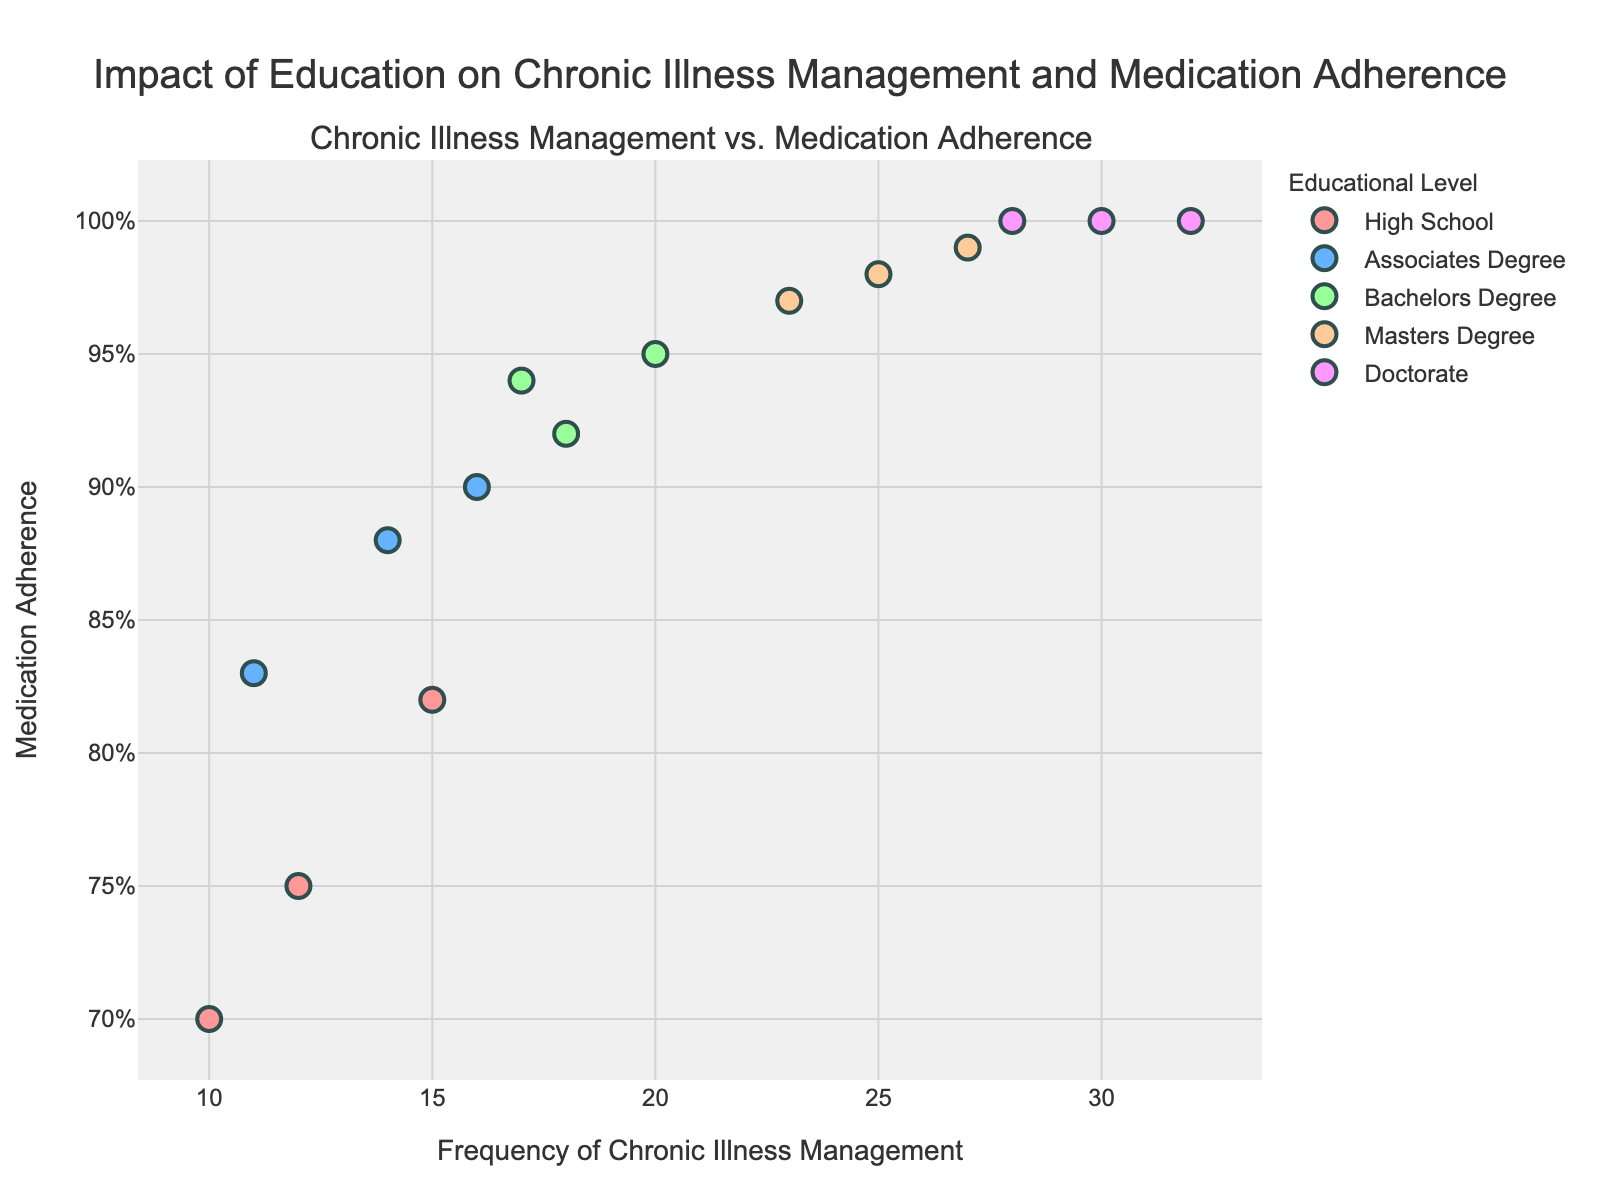Which educational level has the highest frequency of chronic illness management? The educational levels represented in the plot are High School, Associates Degree, Bachelors Degree, Masters Degree, and Doctorate. The Doctorate level has the highest frequency of chronic illness management with values of 30 and 32.
Answer: Doctorate What is the Medication Adherence rate for those with a Master's Degree and a frequency of chronic illness management of 27? From the figure, we can see that the data point for a Master's Degree with a frequency of 27 has a Medication Adherence rate of 99%.
Answer: 99% Which educational level shows a 100% Medication Adherence rate? By inspecting the plot, we can see that the data points for Doctorate all show a Medication Adherence rate of 100%.
Answer: Doctorate What is the range of frequencies of chronic illness management for individuals with a Bachelor's Degree? For people with a Bachelor’s Degree, the data points on the plot indicate frequencies of 17, 18, and 20. Therefore, the range is from 17 to 20.
Answer: 17 to 20 Is there a positive correlation between educational level and medication adherence? Observing the trend in the scatter plot, we see that as the educational level increases (from High School to Doctorate), the Medication Adherence percentage generally increases as well. This indicates a positive correlation.
Answer: Yes How many total data points are plotted for Associates Degree? By counting the number of markers representing the Associates Degree in the plot, we see that there are 3 data points for the Associates Degree educational level.
Answer: 3 Is there any overlap in the Medication Adherence percentage between the High School and Bachelor's Degree educational levels? Checking the plot, we see that the highest Medication Adherence rate for High School is 82%, whereas the lowest for Bachelor's Degree is 92%. Therefore, there is no overlap in their Medication Adherence percentages.
Answer: No What is the difference in the highest frequency of chronic illness management between individuals with a Master's Degree and those with an Associate's Degree? The highest frequency for a Master's Degree is 27, and the highest for an Associate's Degree is 16. The difference between these values is 27 - 16 = 11.
Answer: 11 Which educational level has the most consistent (least variable) Medication Adherence rate? Observing the spread of the points, Doctorate has a consistent Medication Adherence rate of 100% for all its data points, showing no variability.
Answer: Doctorate 